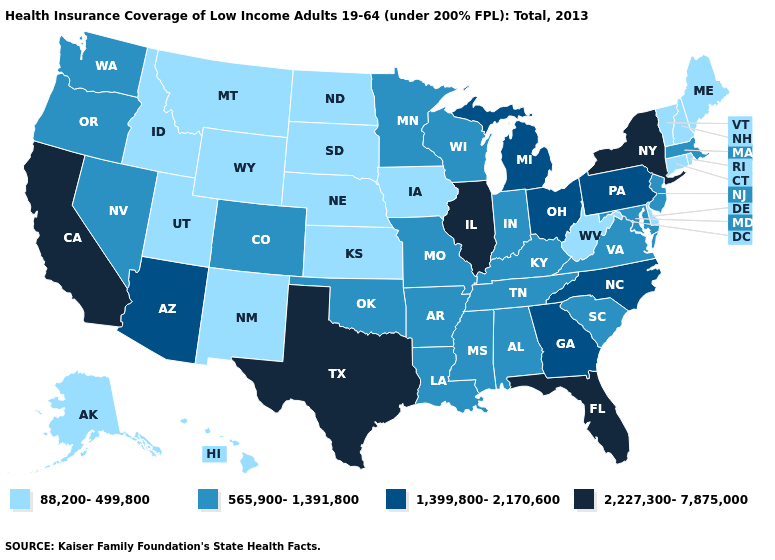What is the highest value in states that border Wyoming?
Write a very short answer. 565,900-1,391,800. Among the states that border Rhode Island , does Massachusetts have the lowest value?
Answer briefly. No. Name the states that have a value in the range 88,200-499,800?
Answer briefly. Alaska, Connecticut, Delaware, Hawaii, Idaho, Iowa, Kansas, Maine, Montana, Nebraska, New Hampshire, New Mexico, North Dakota, Rhode Island, South Dakota, Utah, Vermont, West Virginia, Wyoming. Name the states that have a value in the range 88,200-499,800?
Short answer required. Alaska, Connecticut, Delaware, Hawaii, Idaho, Iowa, Kansas, Maine, Montana, Nebraska, New Hampshire, New Mexico, North Dakota, Rhode Island, South Dakota, Utah, Vermont, West Virginia, Wyoming. What is the highest value in the Northeast ?
Short answer required. 2,227,300-7,875,000. What is the value of North Carolina?
Answer briefly. 1,399,800-2,170,600. What is the value of Alabama?
Keep it brief. 565,900-1,391,800. Name the states that have a value in the range 565,900-1,391,800?
Answer briefly. Alabama, Arkansas, Colorado, Indiana, Kentucky, Louisiana, Maryland, Massachusetts, Minnesota, Mississippi, Missouri, Nevada, New Jersey, Oklahoma, Oregon, South Carolina, Tennessee, Virginia, Washington, Wisconsin. Is the legend a continuous bar?
Short answer required. No. Name the states that have a value in the range 88,200-499,800?
Keep it brief. Alaska, Connecticut, Delaware, Hawaii, Idaho, Iowa, Kansas, Maine, Montana, Nebraska, New Hampshire, New Mexico, North Dakota, Rhode Island, South Dakota, Utah, Vermont, West Virginia, Wyoming. What is the value of Idaho?
Quick response, please. 88,200-499,800. What is the highest value in the Northeast ?
Answer briefly. 2,227,300-7,875,000. Which states have the lowest value in the South?
Answer briefly. Delaware, West Virginia. Does New Hampshire have the lowest value in the Northeast?
Be succinct. Yes. How many symbols are there in the legend?
Be succinct. 4. 